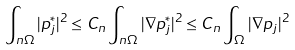Convert formula to latex. <formula><loc_0><loc_0><loc_500><loc_500>\int _ { n \Omega } | p _ { j } ^ { * } | ^ { 2 } \leq C _ { n } \int _ { n \Omega } | \nabla p _ { j } ^ { * } | ^ { 2 } \leq C _ { n } \int _ { \Omega } | \nabla p _ { j } | ^ { 2 }</formula> 